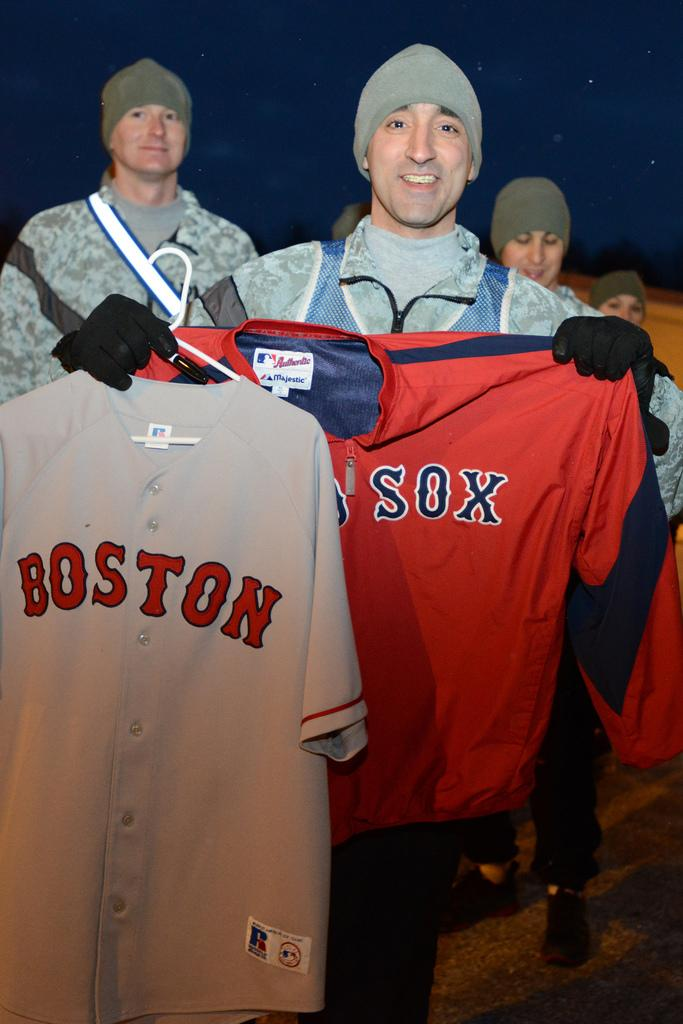<image>
Share a concise interpretation of the image provided. A man holds up a Boston jersey and a jersey that says "sox". 